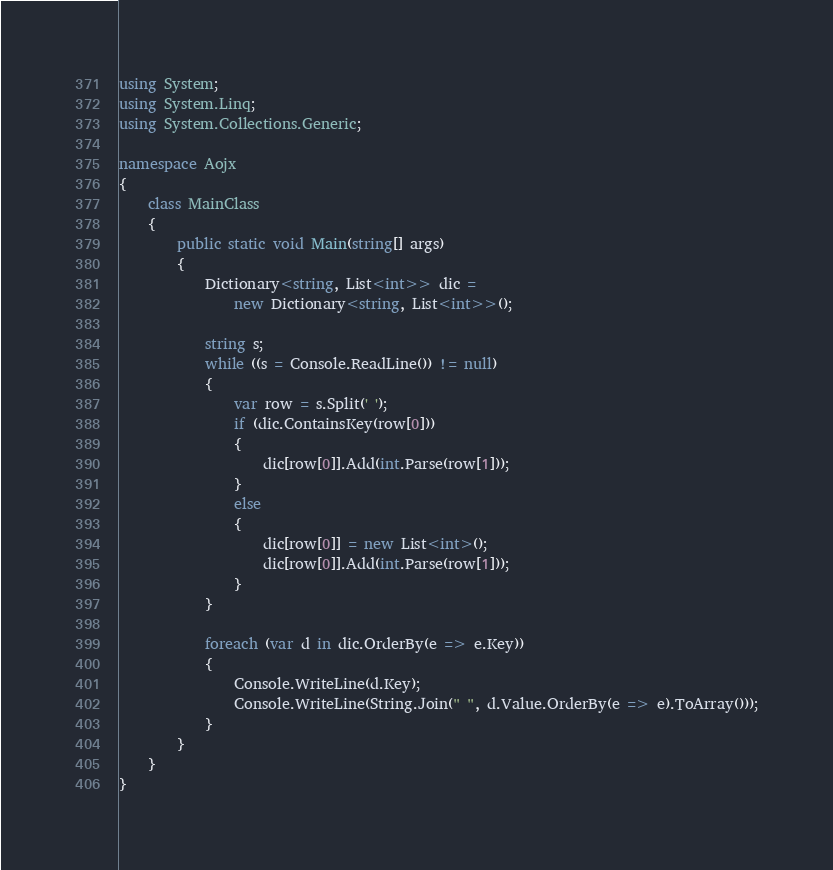<code> <loc_0><loc_0><loc_500><loc_500><_C#_>using System;
using System.Linq;
using System.Collections.Generic;

namespace Aojx
{
    class MainClass
    {
        public static void Main(string[] args)
        {
            Dictionary<string, List<int>> dic =
                new Dictionary<string, List<int>>();
            
            string s;
            while ((s = Console.ReadLine()) != null)
            {
                var row = s.Split(' ');
                if (dic.ContainsKey(row[0]))
                {
                    dic[row[0]].Add(int.Parse(row[1]));
                }
                else
                {
                    dic[row[0]] = new List<int>();
                    dic[row[0]].Add(int.Parse(row[1]));
                }
            }

            foreach (var d in dic.OrderBy(e => e.Key))
            {
                Console.WriteLine(d.Key);
                Console.WriteLine(String.Join(" ", d.Value.OrderBy(e => e).ToArray()));
            }
        }
    }
}</code> 